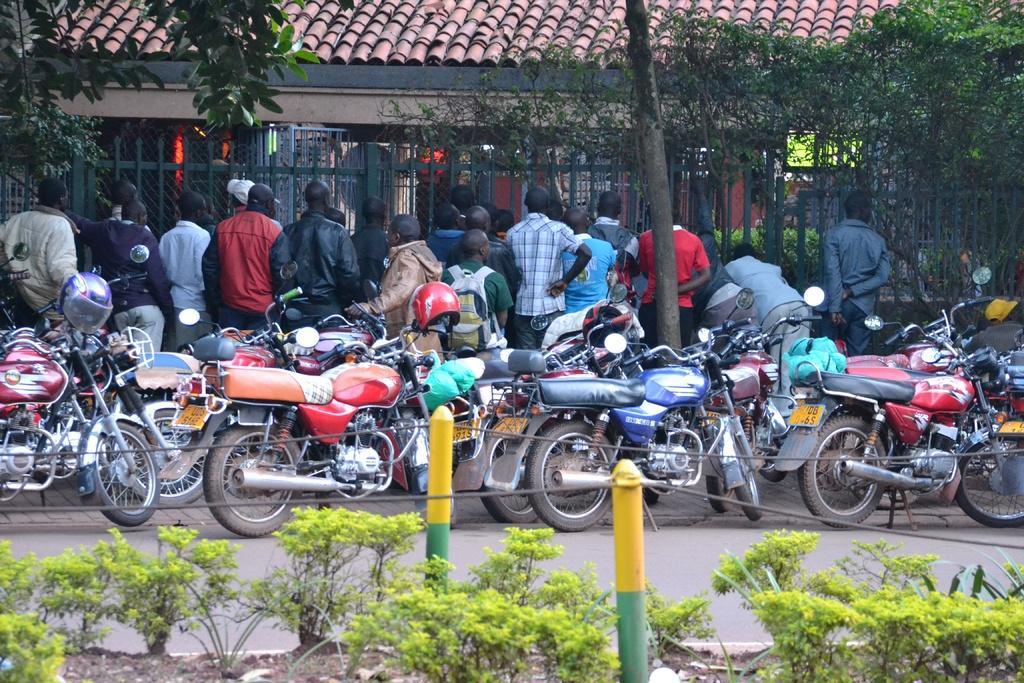Could you give a brief overview of what you see in this image? In this picture I can see few motorcycles and few people standing and I can see a house and few trees and a metal fence and I can see plants. 